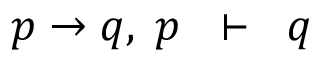<formula> <loc_0><loc_0><loc_500><loc_500>p \to q , \, p \, \vdash \, q</formula> 